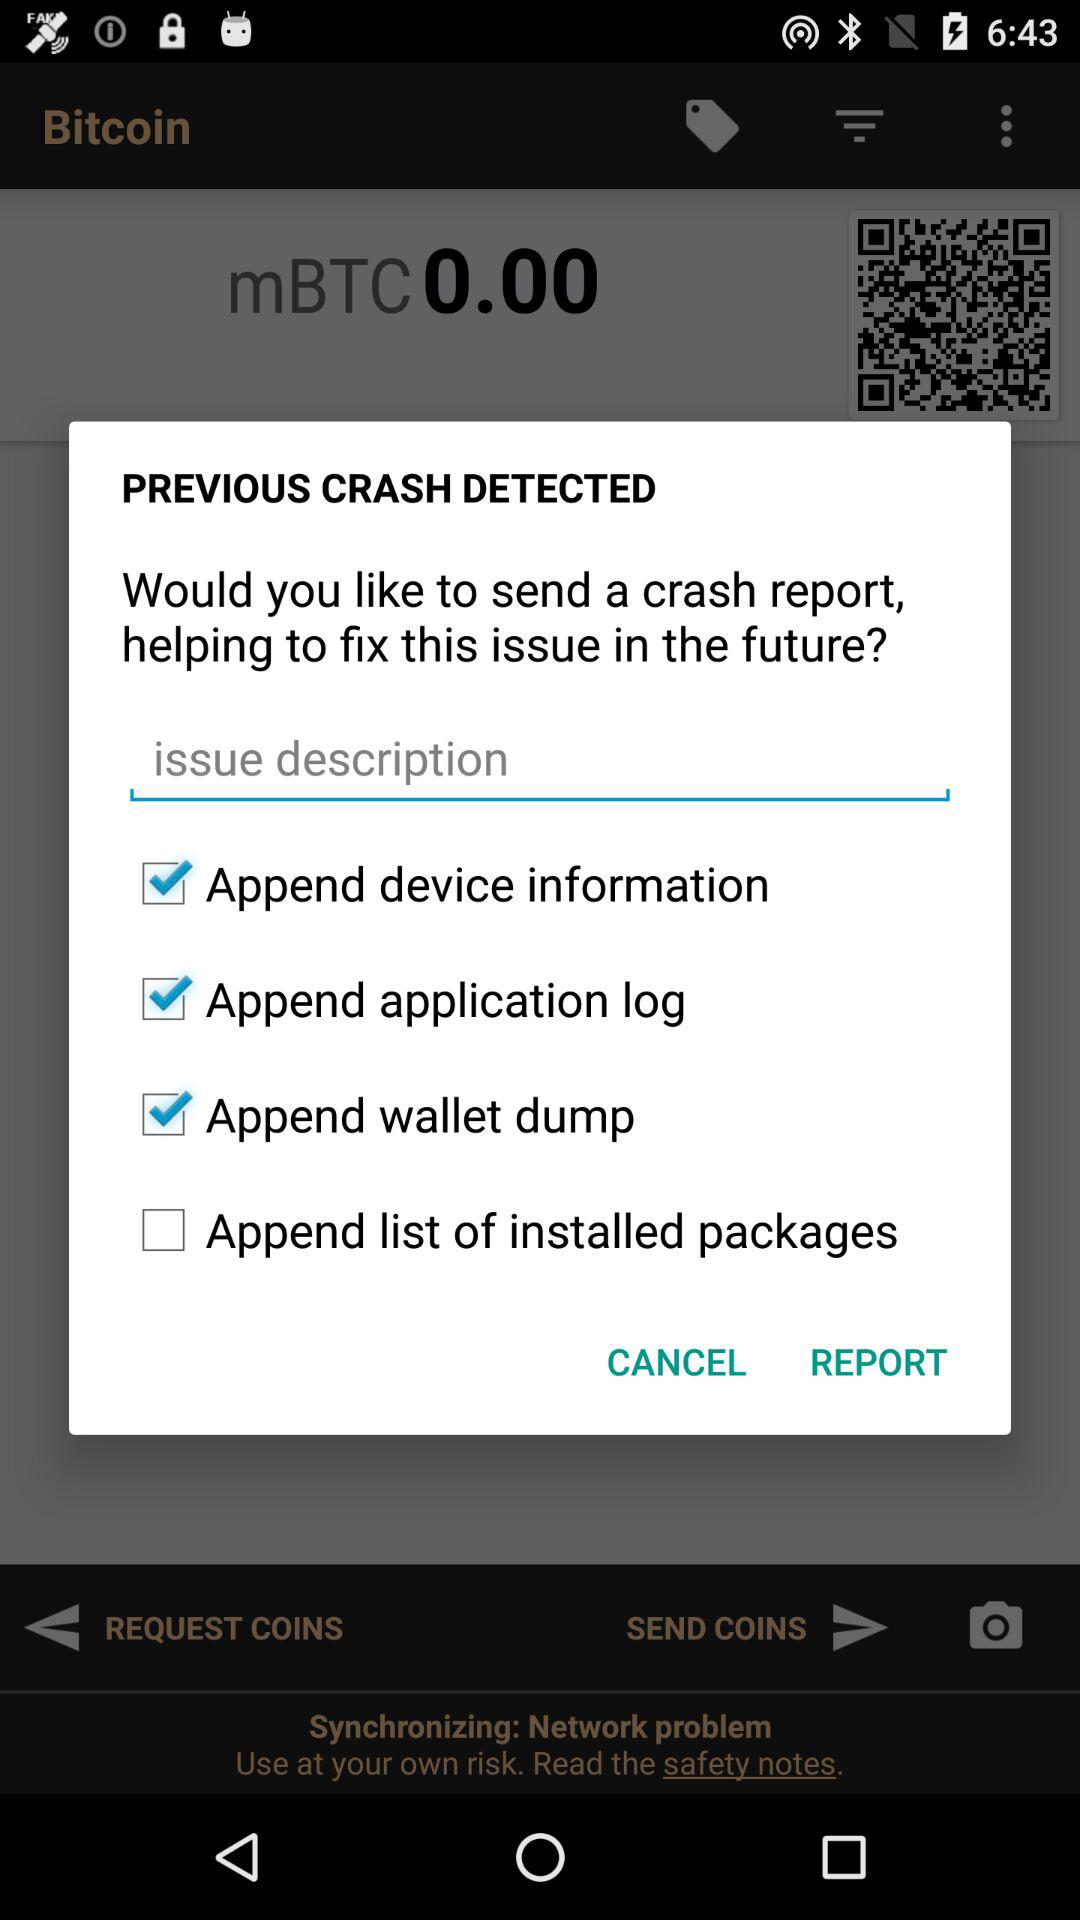What is the status of the "Append application log"? The status is "on". 